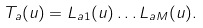Convert formula to latex. <formula><loc_0><loc_0><loc_500><loc_500>T _ { a } ( u ) = L _ { a 1 } ( u ) \dots L _ { a M } ( u ) .</formula> 